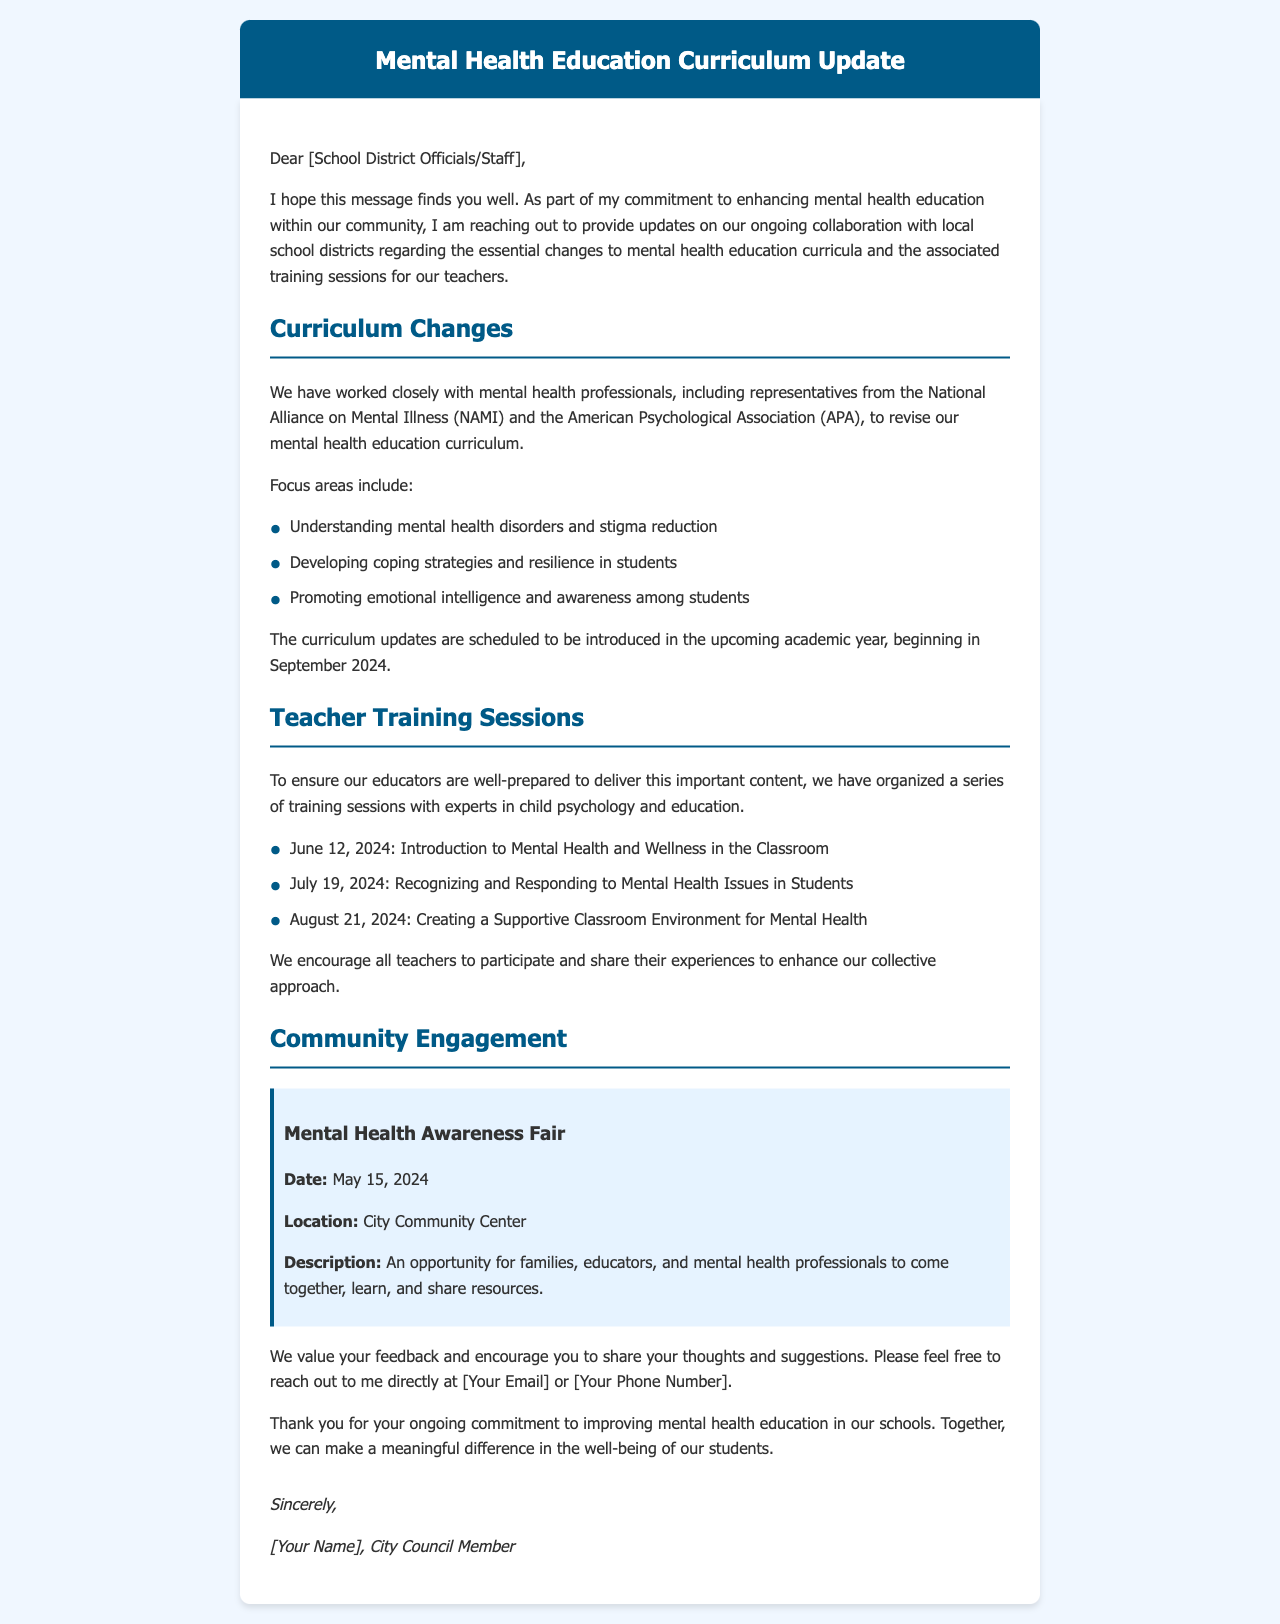What is the primary focus of the curriculum changes? The curriculum changes focus on understanding mental health disorders, coping strategies, and promoting emotional intelligence among students.
Answer: Understanding mental health disorders and stigma reduction When will the curriculum updates be introduced? The curriculum updates are set to be introduced in the upcoming academic year.
Answer: September 2024 What is the date of the Mental Health Awareness Fair? The document specifies the date of the Mental Health Awareness Fair.
Answer: May 15, 2024 Who are the collaborating organizations mentioned in the document? The document mentions organizations involved in curriculum revision.
Answer: National Alliance on Mental Illness (NAMI) and American Psychological Association (APA) How many teacher training sessions are scheduled? The document outlines a specific number of training sessions for teachers.
Answer: Three sessions What is the format of the training session on recognizing mental health issues? The document lists specific training session topics and their aims.
Answer: Recognizing and Responding to Mental Health Issues in Students What is the location of the Mental Health Awareness Fair? The document states the venue for the community event.
Answer: City Community Center What is the main purpose of the email? The document's opening statement outlines the main purpose behind sending the email.
Answer: Enhancing mental health education 